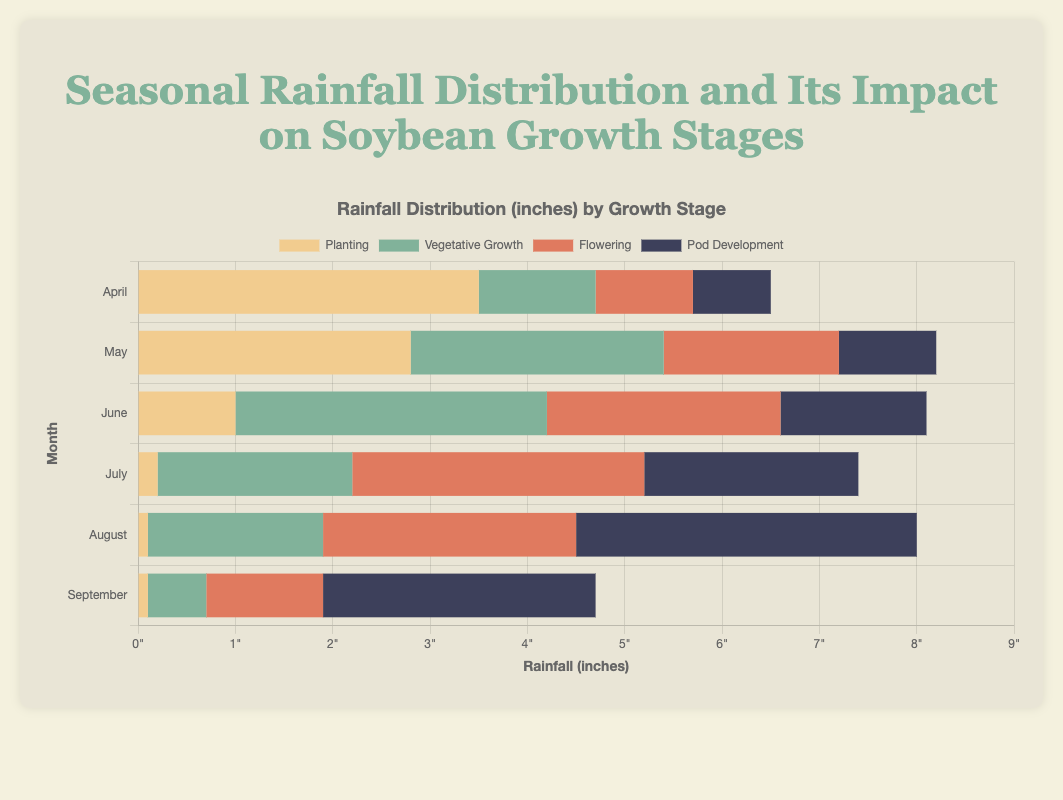What month received the most rainfall for the Planting stage? Look at the Planting bars and identify the month with the tallest bar. The tallest bar for Planting is in April.
Answer: April Which growth stage received the most rainfall in July? Find July on the y-axis and compare the lengths of the bars. The Flowering stage has the longest bar in July.
Answer: Flowering Compare the rainfall for Vegetative Growth between June and August. Which month had more? Look at the lengths of the Vegetative Growth bars in June and August. June's bar is longer than August's.
Answer: June By how much did the rainfall for Pod Development in August exceed that in June? Look at the bars for Pod Development in August and June. Subtract the height of the June bar from the height of the August bar (3.5 - 1.5 = 2.0).
Answer: 2.0 inches What is the average rainfall for the Flowering stage from April to September? Sum the Flowering rainfall from each month and divide by the number of months (1.0 + 1.8 + 2.4 + 3.0 + 2.6 + 1.2 = 12.0; 12.0/6 = 2.0).
Answer: 2.0 inches Is the optimal rainfall for the Vegetative Growth stage higher or lower than the actual rainfall in September? The optimal rainfall for Vegetative Growth is 3.0 inches. The actual rainfall in September is 0.6 inches, which is lower.
Answer: Lower Which month had the least rainfall for Planting, and how much was it? Identify the shortest bar for Planting by comparing all months. The shortest bar is in August, with 0.1 inches of rainfall.
Answer: August, 0.1 inches What is the difference in rainfall between Planting and Pod Development in May? Find the bars for Planting and Pod Development in May. Subtract the height of the Pod Development bar from the Planting bar (2.8 - 1.0 = 1.8).
Answer: 1.8 inches In which month did all stages receive some rainfall? Check each month to see if there is a bar for every growth stage. Each stage has a rainfall bar in May.
Answer: May Compare the total rainfall in June across all stages to that in July. Which month received more total rainfall? Add up the rainfall for all stages in June and July. June: (1.0 + 3.2 + 2.4 + 1.5 = 8.1 inches), July: (0.2 + 2.0 + 3.0 + 2.2 = 7.4 inches). June received more rainfall.
Answer: June 